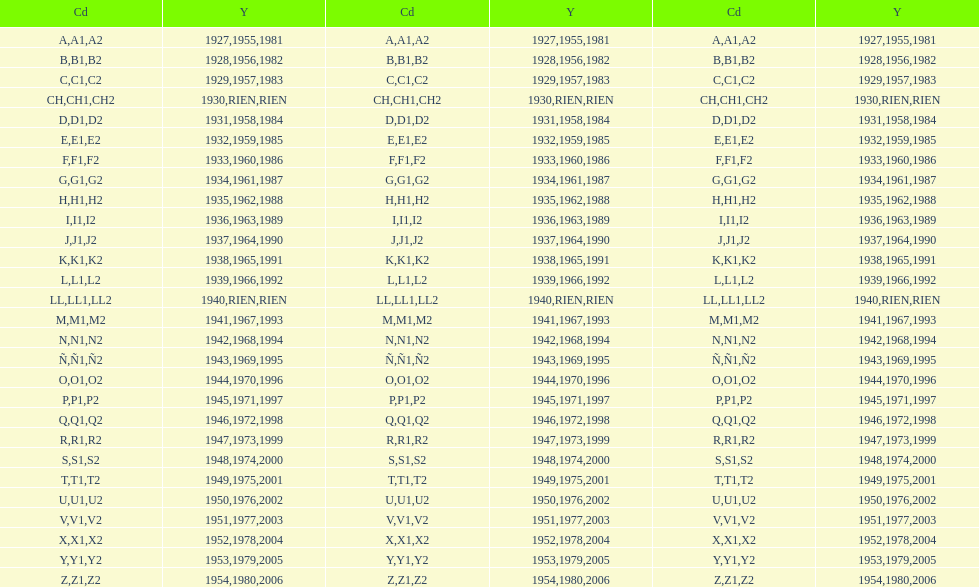Number of codes containing a 2? 28. 